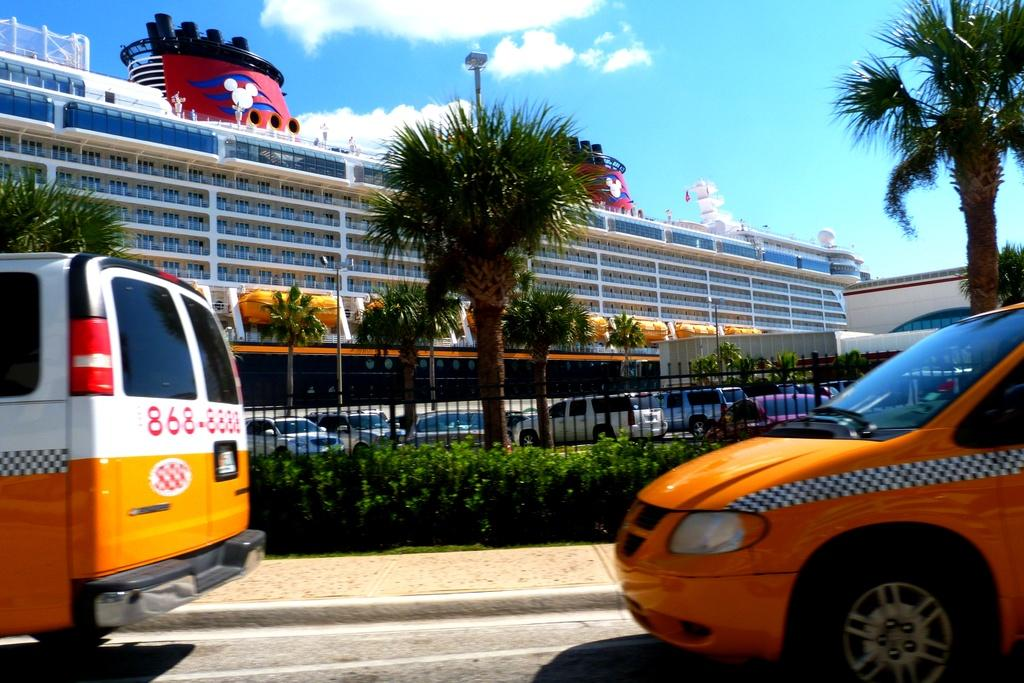Provide a one-sentence caption for the provided image. A van used as a taxi has a phone number written on it, it is 868-8888. 